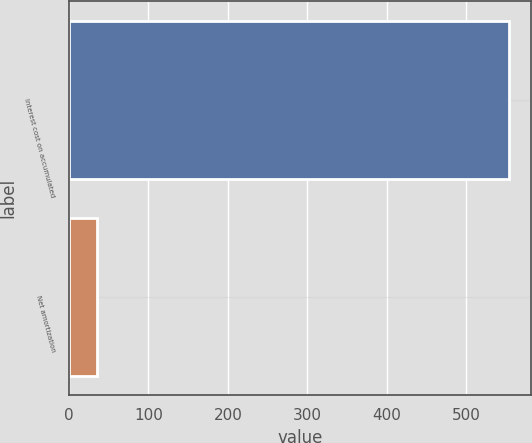Convert chart to OTSL. <chart><loc_0><loc_0><loc_500><loc_500><bar_chart><fcel>Interest cost on accumulated<fcel>Net amortization<nl><fcel>553<fcel>35<nl></chart> 